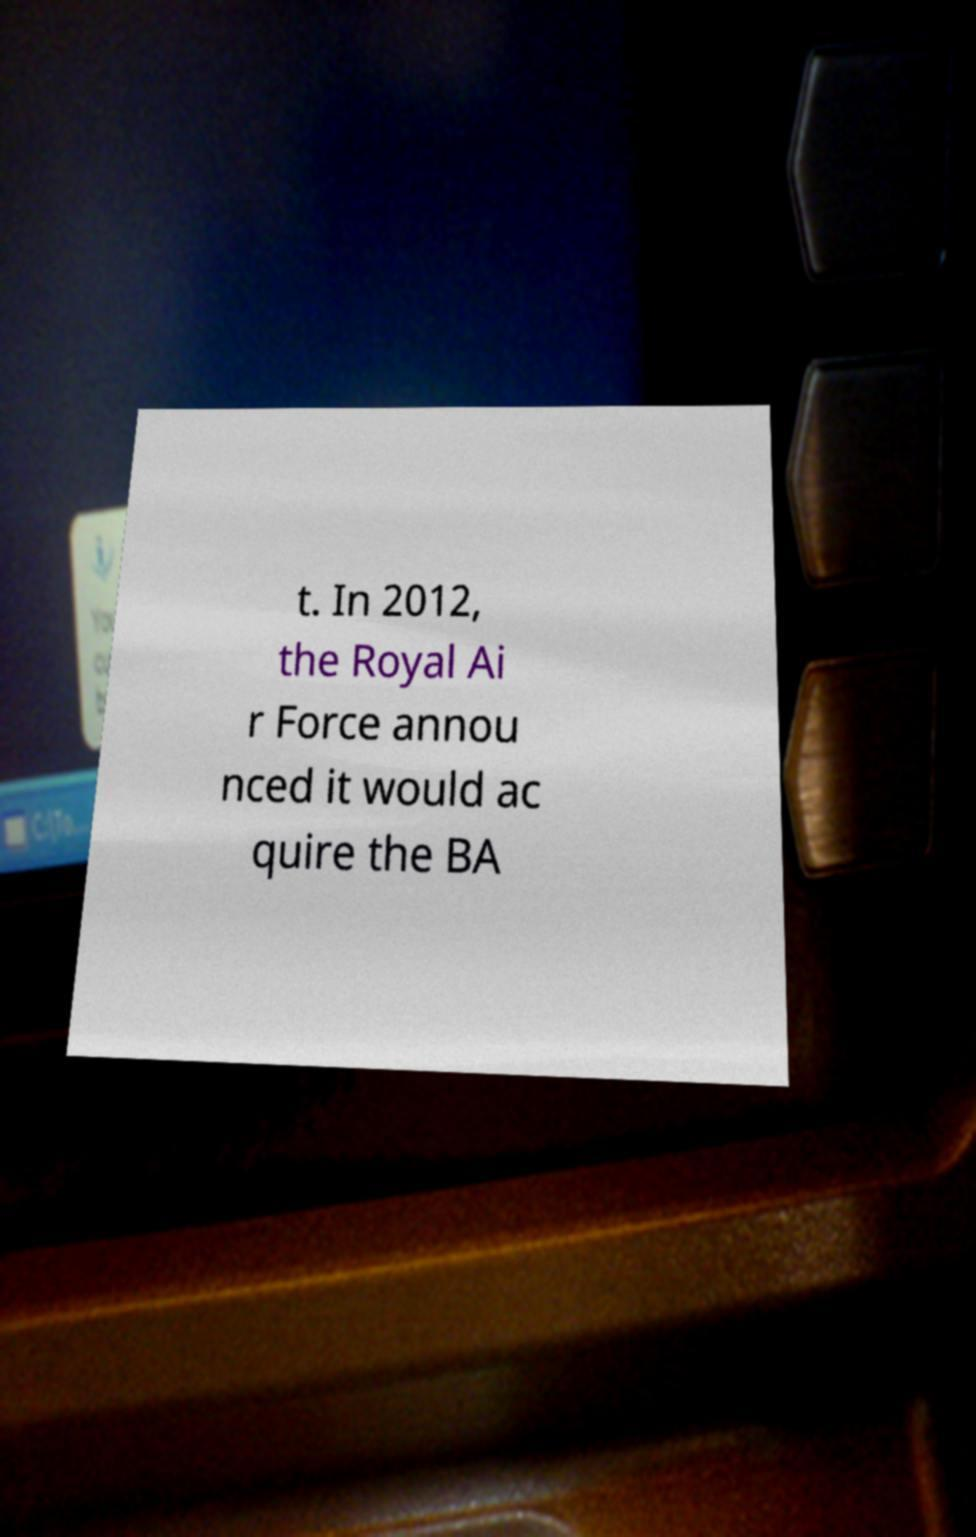Please read and relay the text visible in this image. What does it say? t. In 2012, the Royal Ai r Force annou nced it would ac quire the BA 